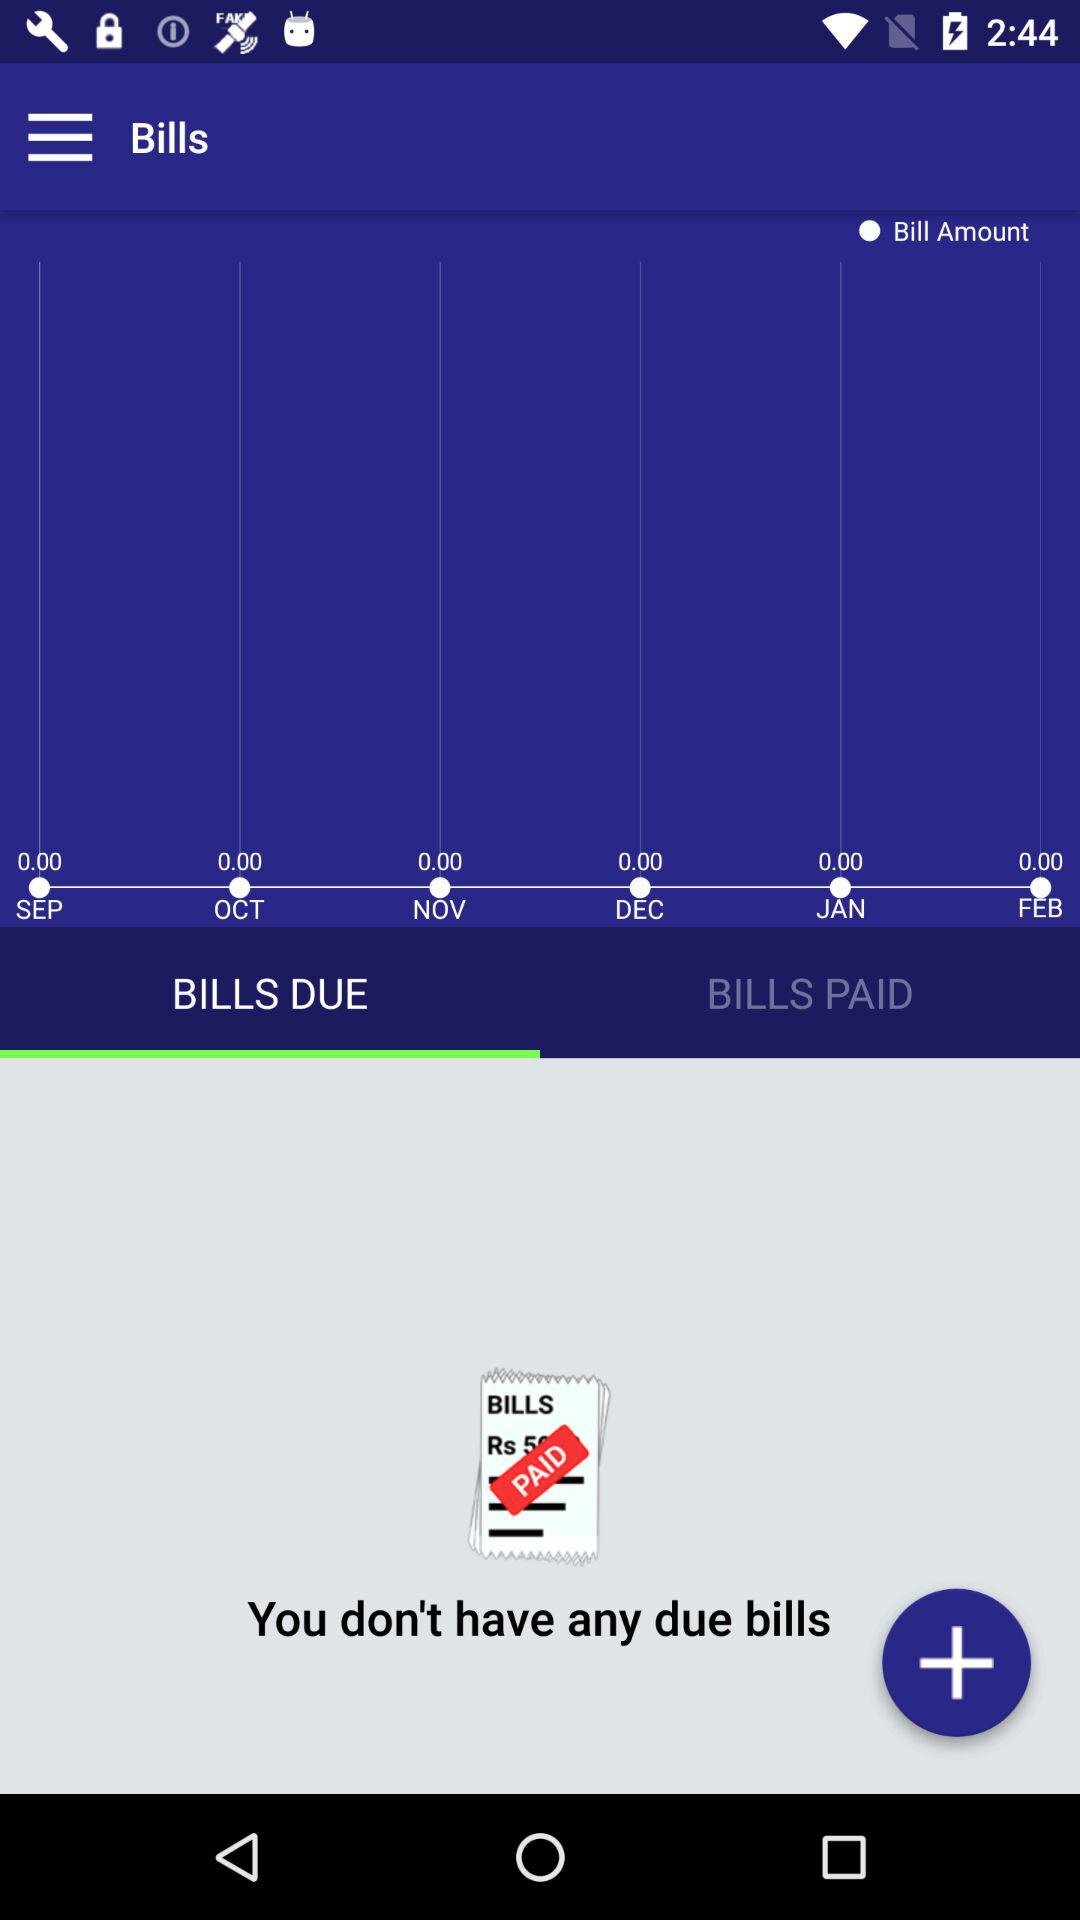How much is the total amount of bills?
Answer the question using a single word or phrase. Rs 50 